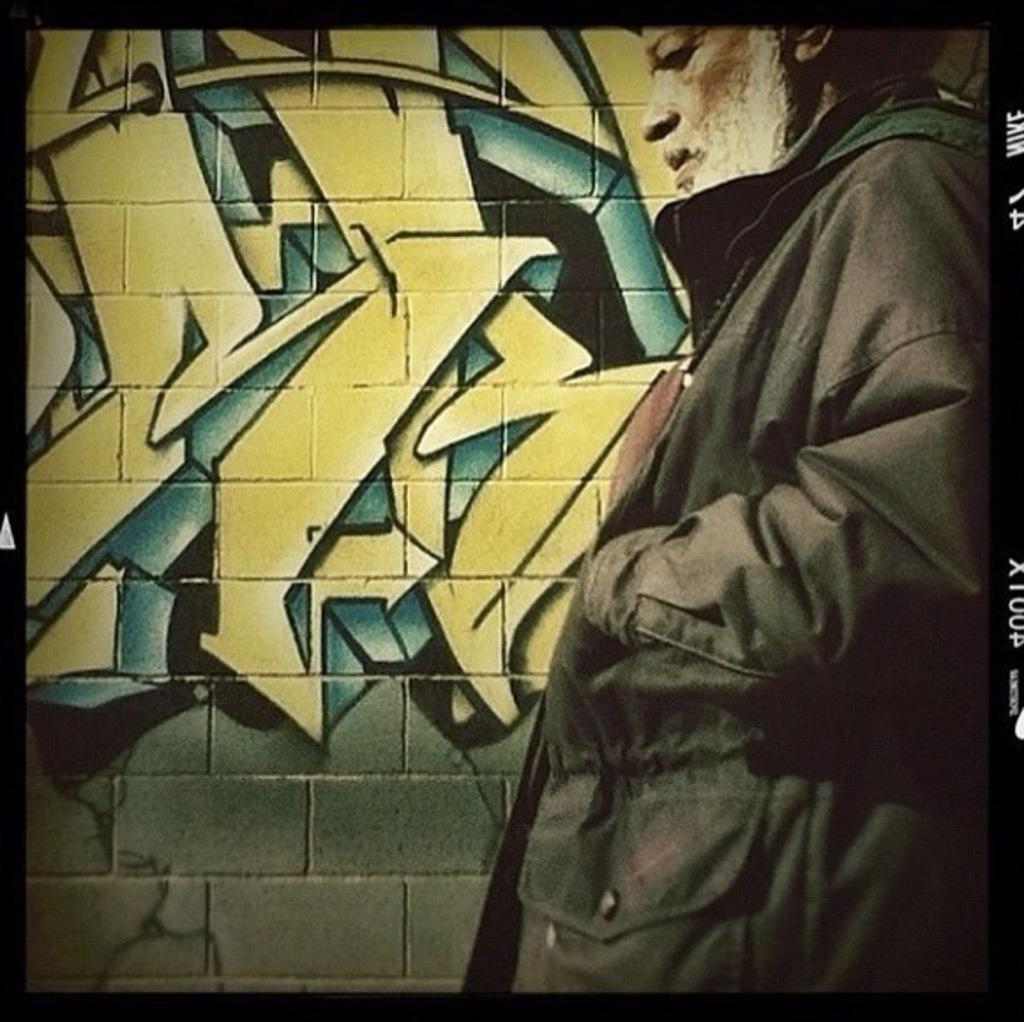Where was the image taken? The image was taken outdoors. What can be seen in the background of the image? There is a wall with graffiti in the background. Can you describe the person on the right side of the image? There is a man on the right side of the image. Is there a woman holding a cork in the image? There is no woman or cork present in the image. 